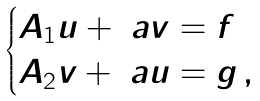Convert formula to latex. <formula><loc_0><loc_0><loc_500><loc_500>\begin{cases} A _ { 1 } u + \ a v = f \\ A _ { 2 } v + \ a u = g \, , \end{cases}</formula> 